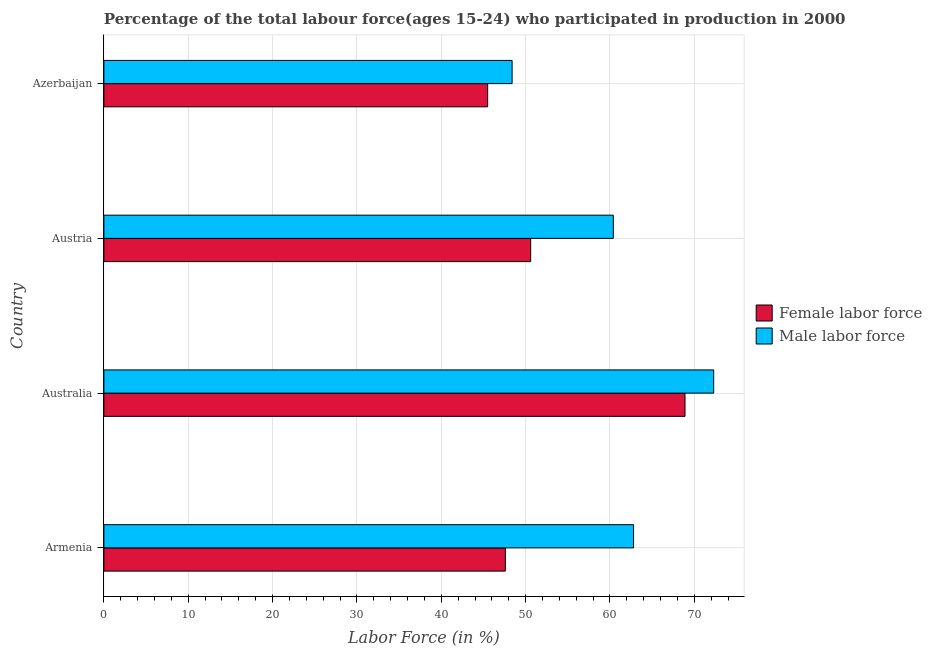How many different coloured bars are there?
Provide a succinct answer. 2. How many bars are there on the 1st tick from the bottom?
Offer a very short reply. 2. What is the label of the 1st group of bars from the top?
Provide a short and direct response. Azerbaijan. In how many cases, is the number of bars for a given country not equal to the number of legend labels?
Offer a terse response. 0. What is the percentage of male labour force in Azerbaijan?
Offer a terse response. 48.4. Across all countries, what is the maximum percentage of female labor force?
Ensure brevity in your answer.  68.9. Across all countries, what is the minimum percentage of female labor force?
Make the answer very short. 45.5. In which country was the percentage of female labor force maximum?
Provide a short and direct response. Australia. In which country was the percentage of female labor force minimum?
Your answer should be very brief. Azerbaijan. What is the total percentage of female labor force in the graph?
Give a very brief answer. 212.6. What is the difference between the percentage of male labour force in Australia and that in Azerbaijan?
Offer a terse response. 23.9. What is the difference between the percentage of male labour force in Australia and the percentage of female labor force in Armenia?
Provide a short and direct response. 24.7. What is the average percentage of female labor force per country?
Give a very brief answer. 53.15. Is the percentage of female labor force in Armenia less than that in Austria?
Your answer should be compact. Yes. What is the difference between the highest and the lowest percentage of female labor force?
Give a very brief answer. 23.4. In how many countries, is the percentage of male labour force greater than the average percentage of male labour force taken over all countries?
Offer a terse response. 2. Is the sum of the percentage of female labor force in Austria and Azerbaijan greater than the maximum percentage of male labour force across all countries?
Provide a succinct answer. Yes. What does the 2nd bar from the top in Australia represents?
Keep it short and to the point. Female labor force. What does the 1st bar from the bottom in Australia represents?
Ensure brevity in your answer.  Female labor force. Does the graph contain any zero values?
Your answer should be compact. No. Does the graph contain grids?
Ensure brevity in your answer.  Yes. How many legend labels are there?
Give a very brief answer. 2. How are the legend labels stacked?
Offer a very short reply. Vertical. What is the title of the graph?
Make the answer very short. Percentage of the total labour force(ages 15-24) who participated in production in 2000. Does "Ages 15-24" appear as one of the legend labels in the graph?
Keep it short and to the point. No. What is the label or title of the X-axis?
Your answer should be compact. Labor Force (in %). What is the label or title of the Y-axis?
Provide a succinct answer. Country. What is the Labor Force (in %) of Female labor force in Armenia?
Provide a short and direct response. 47.6. What is the Labor Force (in %) of Male labor force in Armenia?
Offer a very short reply. 62.8. What is the Labor Force (in %) in Female labor force in Australia?
Your response must be concise. 68.9. What is the Labor Force (in %) in Male labor force in Australia?
Provide a short and direct response. 72.3. What is the Labor Force (in %) of Female labor force in Austria?
Offer a very short reply. 50.6. What is the Labor Force (in %) of Male labor force in Austria?
Offer a very short reply. 60.4. What is the Labor Force (in %) of Female labor force in Azerbaijan?
Your response must be concise. 45.5. What is the Labor Force (in %) in Male labor force in Azerbaijan?
Give a very brief answer. 48.4. Across all countries, what is the maximum Labor Force (in %) of Female labor force?
Provide a succinct answer. 68.9. Across all countries, what is the maximum Labor Force (in %) of Male labor force?
Your answer should be very brief. 72.3. Across all countries, what is the minimum Labor Force (in %) of Female labor force?
Give a very brief answer. 45.5. Across all countries, what is the minimum Labor Force (in %) of Male labor force?
Keep it short and to the point. 48.4. What is the total Labor Force (in %) in Female labor force in the graph?
Make the answer very short. 212.6. What is the total Labor Force (in %) of Male labor force in the graph?
Make the answer very short. 243.9. What is the difference between the Labor Force (in %) of Female labor force in Armenia and that in Australia?
Your response must be concise. -21.3. What is the difference between the Labor Force (in %) in Male labor force in Armenia and that in Australia?
Provide a succinct answer. -9.5. What is the difference between the Labor Force (in %) in Male labor force in Armenia and that in Austria?
Provide a short and direct response. 2.4. What is the difference between the Labor Force (in %) of Male labor force in Armenia and that in Azerbaijan?
Your answer should be very brief. 14.4. What is the difference between the Labor Force (in %) in Female labor force in Australia and that in Azerbaijan?
Provide a short and direct response. 23.4. What is the difference between the Labor Force (in %) of Male labor force in Australia and that in Azerbaijan?
Keep it short and to the point. 23.9. What is the difference between the Labor Force (in %) of Female labor force in Austria and that in Azerbaijan?
Your answer should be very brief. 5.1. What is the difference between the Labor Force (in %) in Female labor force in Armenia and the Labor Force (in %) in Male labor force in Australia?
Your response must be concise. -24.7. What is the difference between the Labor Force (in %) of Female labor force in Australia and the Labor Force (in %) of Male labor force in Austria?
Provide a short and direct response. 8.5. What is the difference between the Labor Force (in %) in Female labor force in Australia and the Labor Force (in %) in Male labor force in Azerbaijan?
Your response must be concise. 20.5. What is the average Labor Force (in %) in Female labor force per country?
Make the answer very short. 53.15. What is the average Labor Force (in %) in Male labor force per country?
Your answer should be compact. 60.98. What is the difference between the Labor Force (in %) of Female labor force and Labor Force (in %) of Male labor force in Armenia?
Offer a very short reply. -15.2. What is the ratio of the Labor Force (in %) of Female labor force in Armenia to that in Australia?
Make the answer very short. 0.69. What is the ratio of the Labor Force (in %) in Male labor force in Armenia to that in Australia?
Provide a short and direct response. 0.87. What is the ratio of the Labor Force (in %) in Female labor force in Armenia to that in Austria?
Provide a short and direct response. 0.94. What is the ratio of the Labor Force (in %) of Male labor force in Armenia to that in Austria?
Make the answer very short. 1.04. What is the ratio of the Labor Force (in %) of Female labor force in Armenia to that in Azerbaijan?
Offer a very short reply. 1.05. What is the ratio of the Labor Force (in %) of Male labor force in Armenia to that in Azerbaijan?
Your answer should be compact. 1.3. What is the ratio of the Labor Force (in %) in Female labor force in Australia to that in Austria?
Provide a short and direct response. 1.36. What is the ratio of the Labor Force (in %) in Male labor force in Australia to that in Austria?
Provide a succinct answer. 1.2. What is the ratio of the Labor Force (in %) of Female labor force in Australia to that in Azerbaijan?
Give a very brief answer. 1.51. What is the ratio of the Labor Force (in %) in Male labor force in Australia to that in Azerbaijan?
Provide a short and direct response. 1.49. What is the ratio of the Labor Force (in %) in Female labor force in Austria to that in Azerbaijan?
Provide a succinct answer. 1.11. What is the ratio of the Labor Force (in %) in Male labor force in Austria to that in Azerbaijan?
Your answer should be very brief. 1.25. What is the difference between the highest and the second highest Labor Force (in %) in Female labor force?
Offer a terse response. 18.3. What is the difference between the highest and the second highest Labor Force (in %) of Male labor force?
Ensure brevity in your answer.  9.5. What is the difference between the highest and the lowest Labor Force (in %) in Female labor force?
Offer a terse response. 23.4. What is the difference between the highest and the lowest Labor Force (in %) of Male labor force?
Provide a succinct answer. 23.9. 